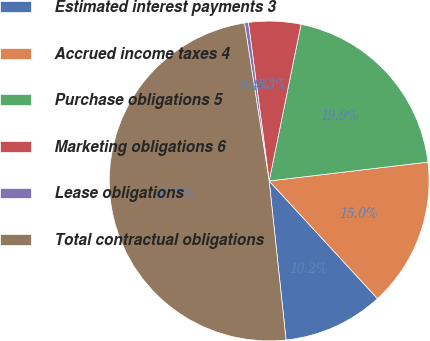<chart> <loc_0><loc_0><loc_500><loc_500><pie_chart><fcel>Estimated interest payments 3<fcel>Accrued income taxes 4<fcel>Purchase obligations 5<fcel>Marketing obligations 6<fcel>Lease obligations<fcel>Total contractual obligations<nl><fcel>10.16%<fcel>15.04%<fcel>19.92%<fcel>5.27%<fcel>0.39%<fcel>49.22%<nl></chart> 